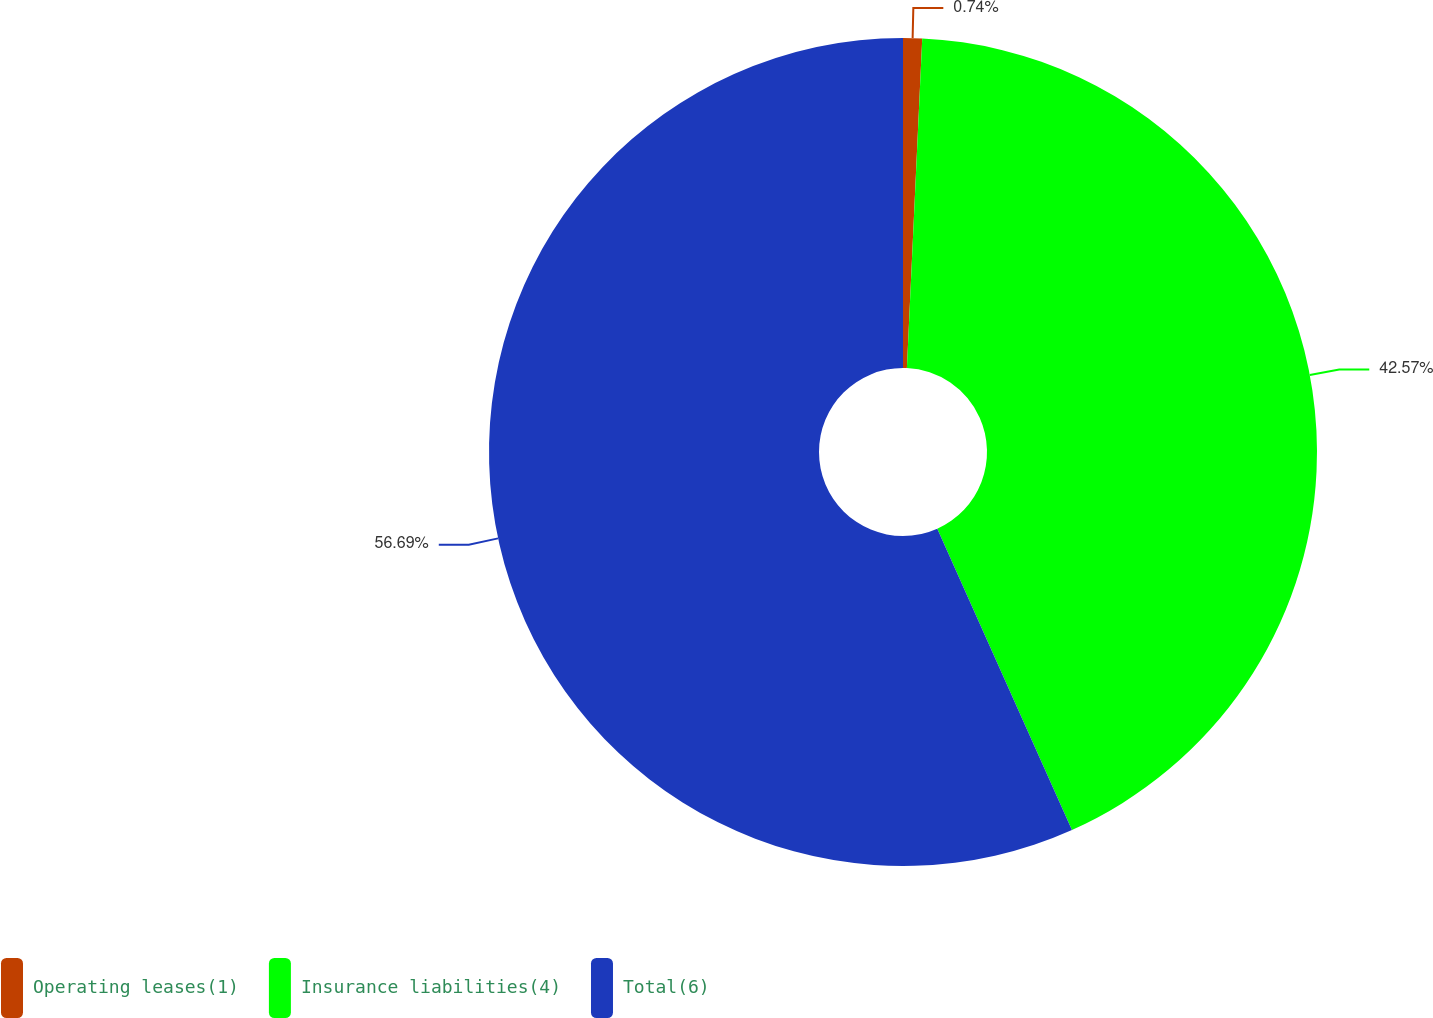Convert chart. <chart><loc_0><loc_0><loc_500><loc_500><pie_chart><fcel>Operating leases(1)<fcel>Insurance liabilities(4)<fcel>Total(6)<nl><fcel>0.74%<fcel>42.57%<fcel>56.69%<nl></chart> 